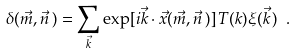Convert formula to latex. <formula><loc_0><loc_0><loc_500><loc_500>\delta ( \vec { m } , \vec { n } \, ) = \sum _ { \vec { k } } \exp [ i \vec { k } \cdot \vec { x } ( \vec { m } , \vec { n } \, ) ] \, T ( k ) \xi ( \vec { k } \, ) \ .</formula> 